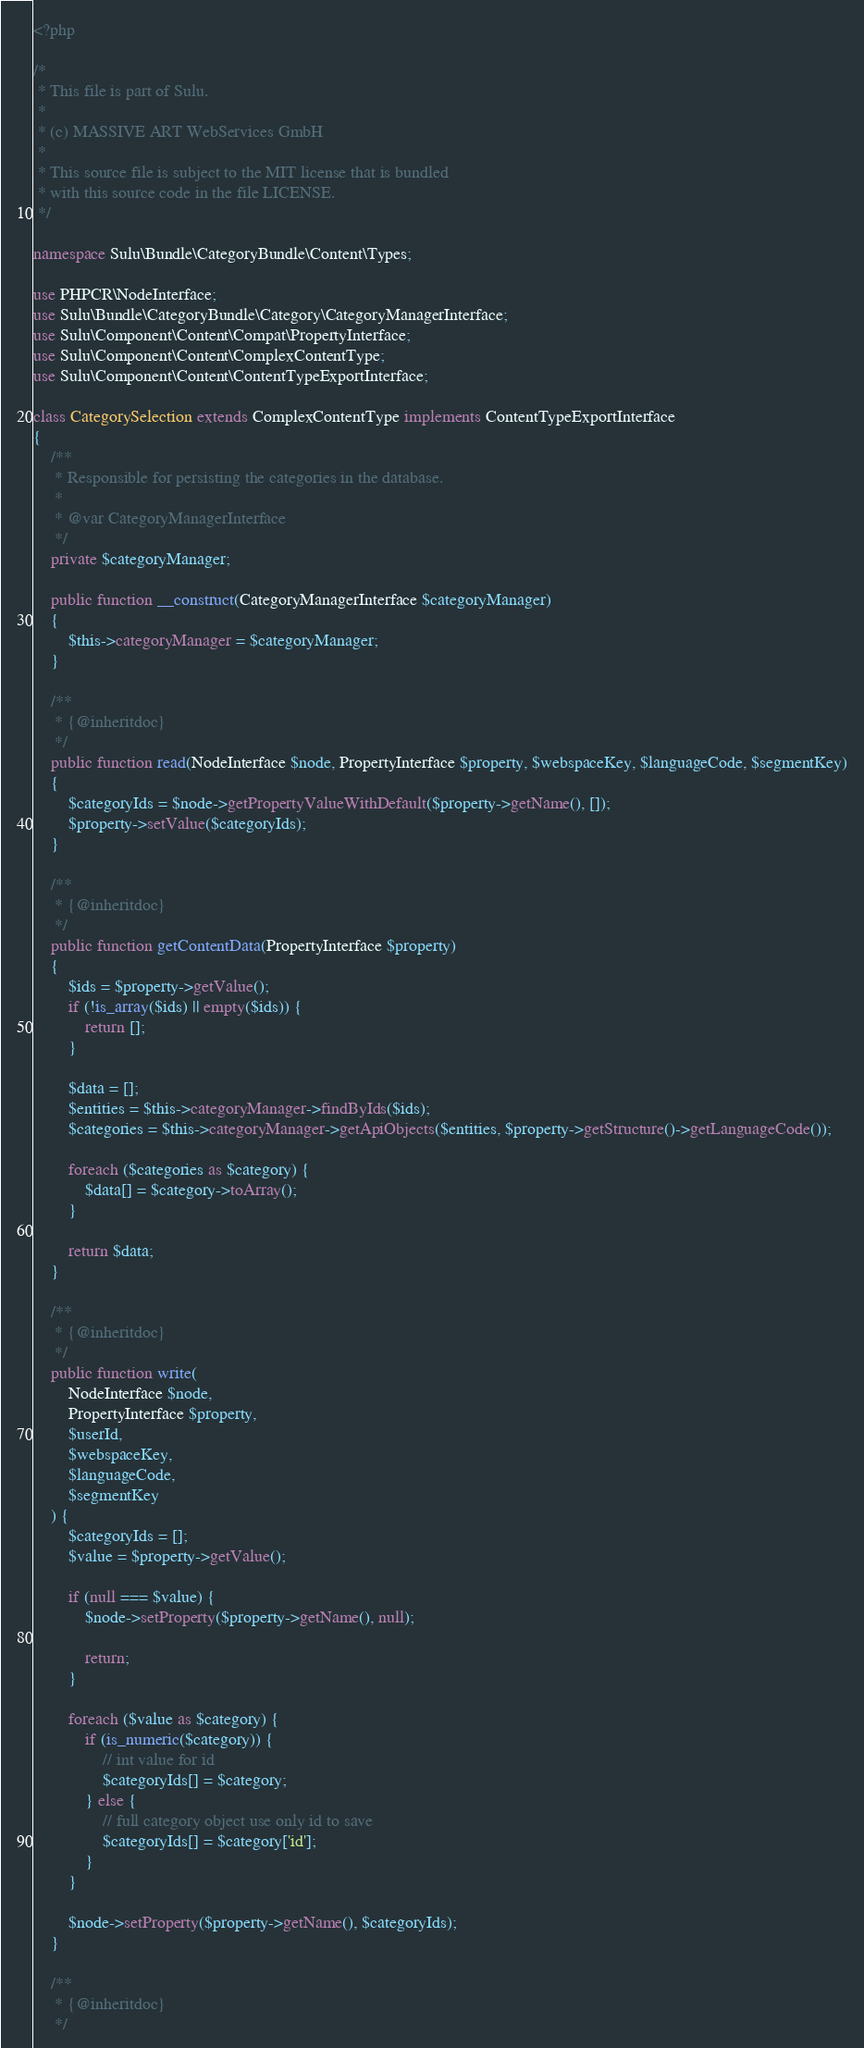<code> <loc_0><loc_0><loc_500><loc_500><_PHP_><?php

/*
 * This file is part of Sulu.
 *
 * (c) MASSIVE ART WebServices GmbH
 *
 * This source file is subject to the MIT license that is bundled
 * with this source code in the file LICENSE.
 */

namespace Sulu\Bundle\CategoryBundle\Content\Types;

use PHPCR\NodeInterface;
use Sulu\Bundle\CategoryBundle\Category\CategoryManagerInterface;
use Sulu\Component\Content\Compat\PropertyInterface;
use Sulu\Component\Content\ComplexContentType;
use Sulu\Component\Content\ContentTypeExportInterface;

class CategorySelection extends ComplexContentType implements ContentTypeExportInterface
{
    /**
     * Responsible for persisting the categories in the database.
     *
     * @var CategoryManagerInterface
     */
    private $categoryManager;

    public function __construct(CategoryManagerInterface $categoryManager)
    {
        $this->categoryManager = $categoryManager;
    }

    /**
     * {@inheritdoc}
     */
    public function read(NodeInterface $node, PropertyInterface $property, $webspaceKey, $languageCode, $segmentKey)
    {
        $categoryIds = $node->getPropertyValueWithDefault($property->getName(), []);
        $property->setValue($categoryIds);
    }

    /**
     * {@inheritdoc}
     */
    public function getContentData(PropertyInterface $property)
    {
        $ids = $property->getValue();
        if (!is_array($ids) || empty($ids)) {
            return [];
        }

        $data = [];
        $entities = $this->categoryManager->findByIds($ids);
        $categories = $this->categoryManager->getApiObjects($entities, $property->getStructure()->getLanguageCode());

        foreach ($categories as $category) {
            $data[] = $category->toArray();
        }

        return $data;
    }

    /**
     * {@inheritdoc}
     */
    public function write(
        NodeInterface $node,
        PropertyInterface $property,
        $userId,
        $webspaceKey,
        $languageCode,
        $segmentKey
    ) {
        $categoryIds = [];
        $value = $property->getValue();

        if (null === $value) {
            $node->setProperty($property->getName(), null);

            return;
        }

        foreach ($value as $category) {
            if (is_numeric($category)) {
                // int value for id
                $categoryIds[] = $category;
            } else {
                // full category object use only id to save
                $categoryIds[] = $category['id'];
            }
        }

        $node->setProperty($property->getName(), $categoryIds);
    }

    /**
     * {@inheritdoc}
     */</code> 